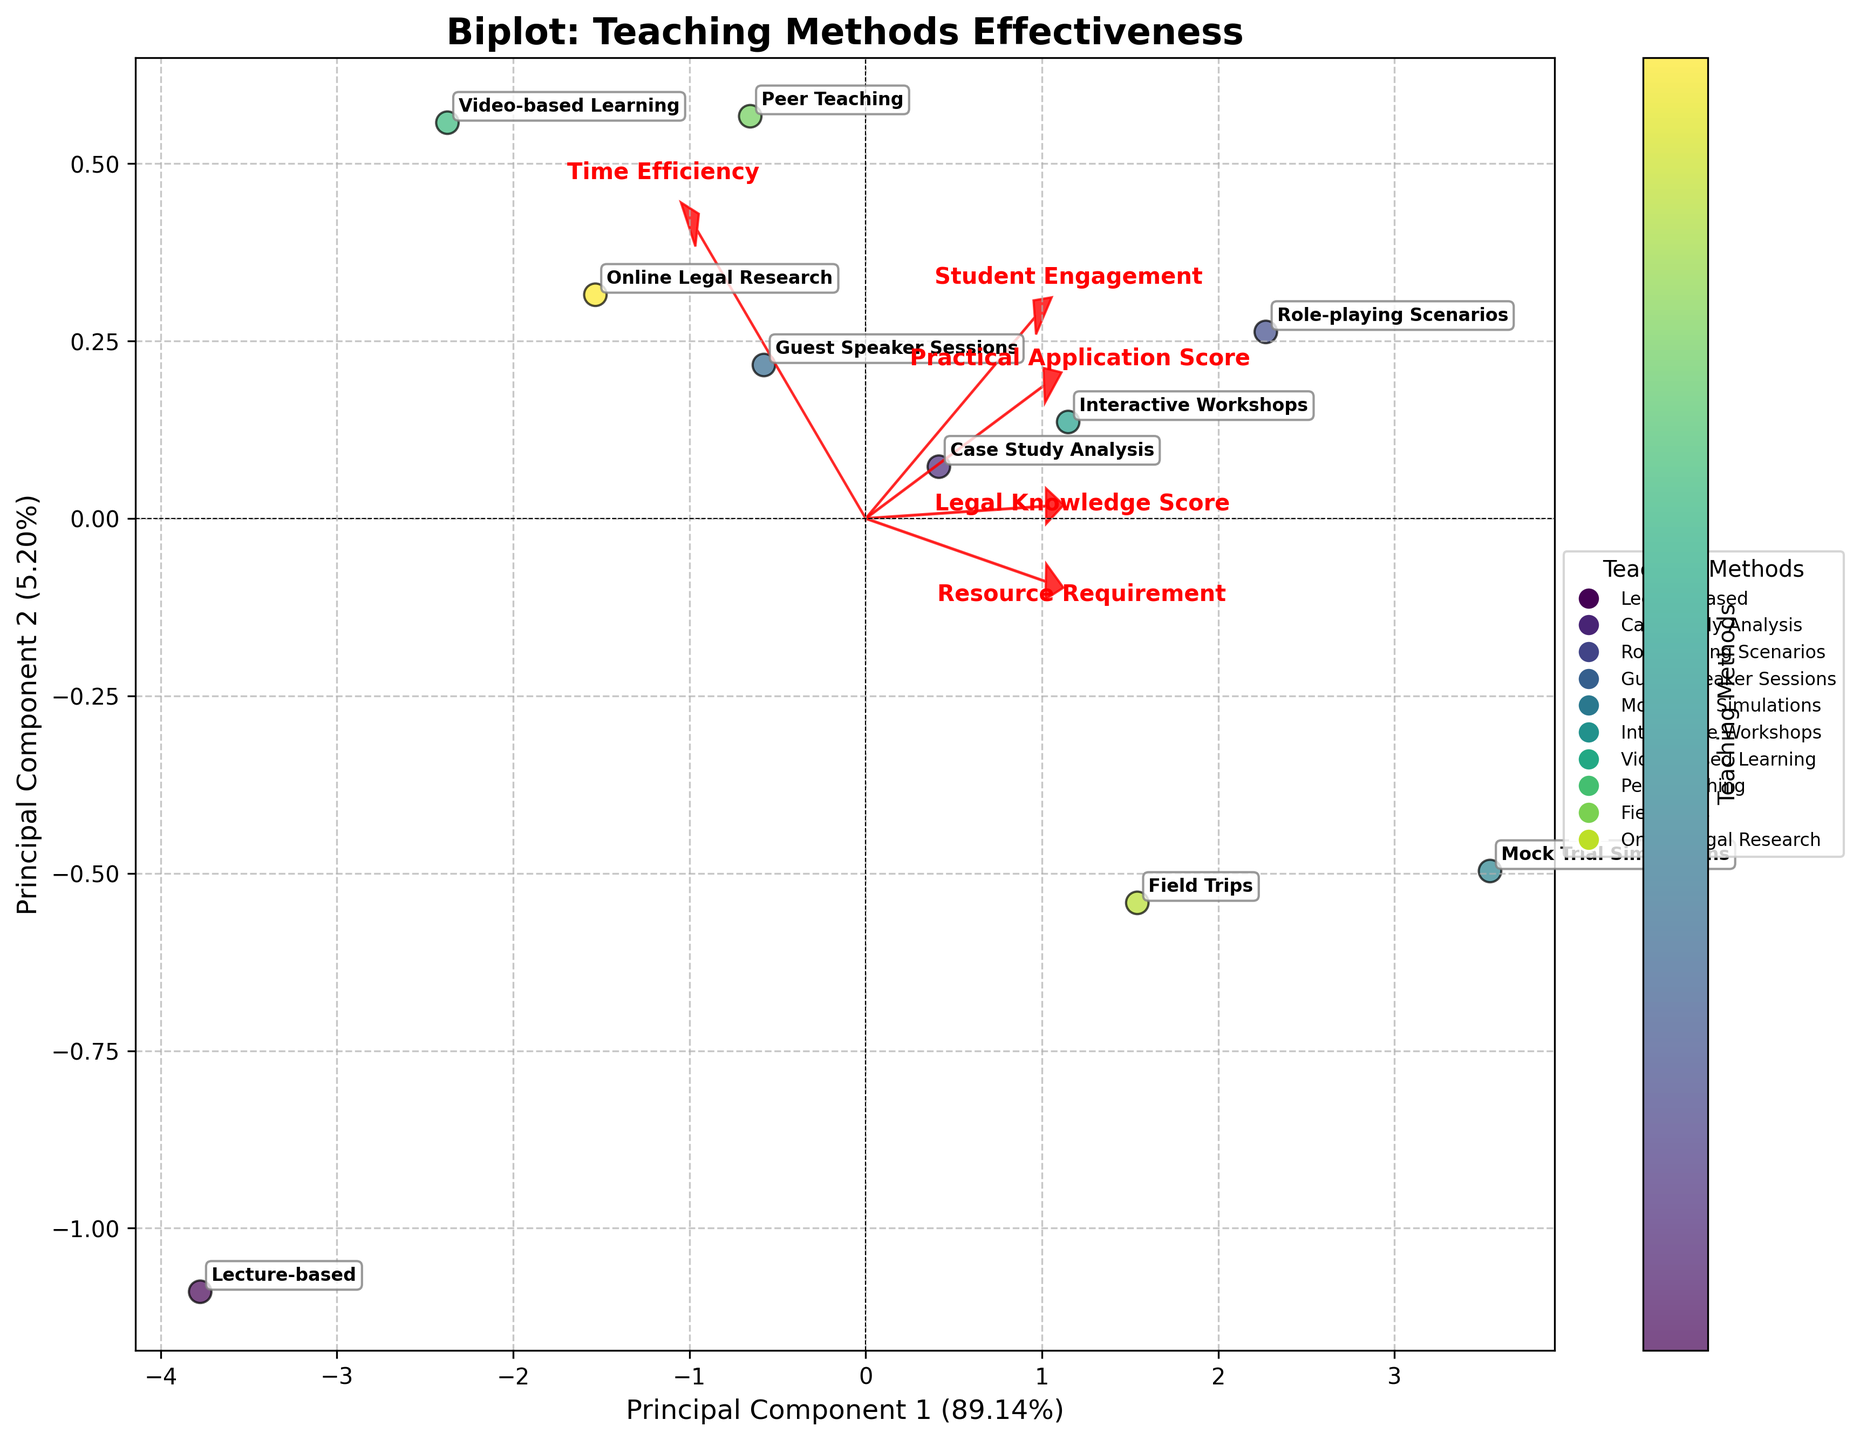What's the title of the biplot? The title is typically displayed prominently at the top of the figure. In this case, the title is "Biplot: Teaching Methods Effectiveness".
Answer: Biplot: Teaching Methods Effectiveness How many teaching methods are compared in this biplot? Each distinct point on the plot represents a different teaching method. By counting these points, we can determine the number of methods compared. The figure shows 10 unique teaching methods.
Answer: 10 Which teaching method is closest to the highest value for Principal Component 1? The points on the plot are labeled with the teaching methods. By locating the point furthest along the x-axis (highest value for Principal Component 1), we see that "Mock Trial Simulations" is closest to this value.
Answer: Mock Trial Simulations Which two features are represented by the longest arrows in the biplot? The arrows represent features, and the length of the arrows indicates their contribution to the principal components. The two longest arrows, i.e., those extending the furthest from the origin, represent "Student Engagement" and "Resource Requirement".
Answer: Student Engagement, Resource Requirement What is the approximate percentage of variation explained by the first principal component? The percentage of variation explained by each principal component is usually given along the axis labels. In this figure, Principal Component 1 explains approximately 45.43% of the variation, as indicated by the x-axis label.
Answer: ~45.43% Which teaching method combines a high "Practical Application Score" and high "Student Engagement"? By identifying the direction of the arrows for "Practical Application Score" and "Student Engagement," we can look for points (teaching methods) that align well with these directions. "Mock Trial Simulations" aligns closely with both arrows, indicating high scores in both areas.
Answer: Mock Trial Simulations How do "Lecture-based" and "Online Legal Research" methods compare in terms of their positions on Principal Component 1? By locating these two methods on the plot and comparing their x-axis positions, we can see that "Lecture-based" is positioned more negatively compared to "Online Legal Research," suggesting the latter has a higher value on Principal Component 1.
Answer: Online Legal Research > Lecture-based What teaching method requires the least resource as depicted in the plot? The length and direction of the "Resource Requirement" arrow indicate which points (teaching methods) require fewer resources. The method that is closest to the opposite direction of this arrow is "Lecture-based".
Answer: Lecture-based Which teaching method appears to be the most time-efficient according to the biplot? From the direction of the "Time Efficiency" arrow, the teaching methods positioned closest to this direction are the most time-efficient. "Lecture-based" is closest to this arrow.
Answer: Lecture-based 